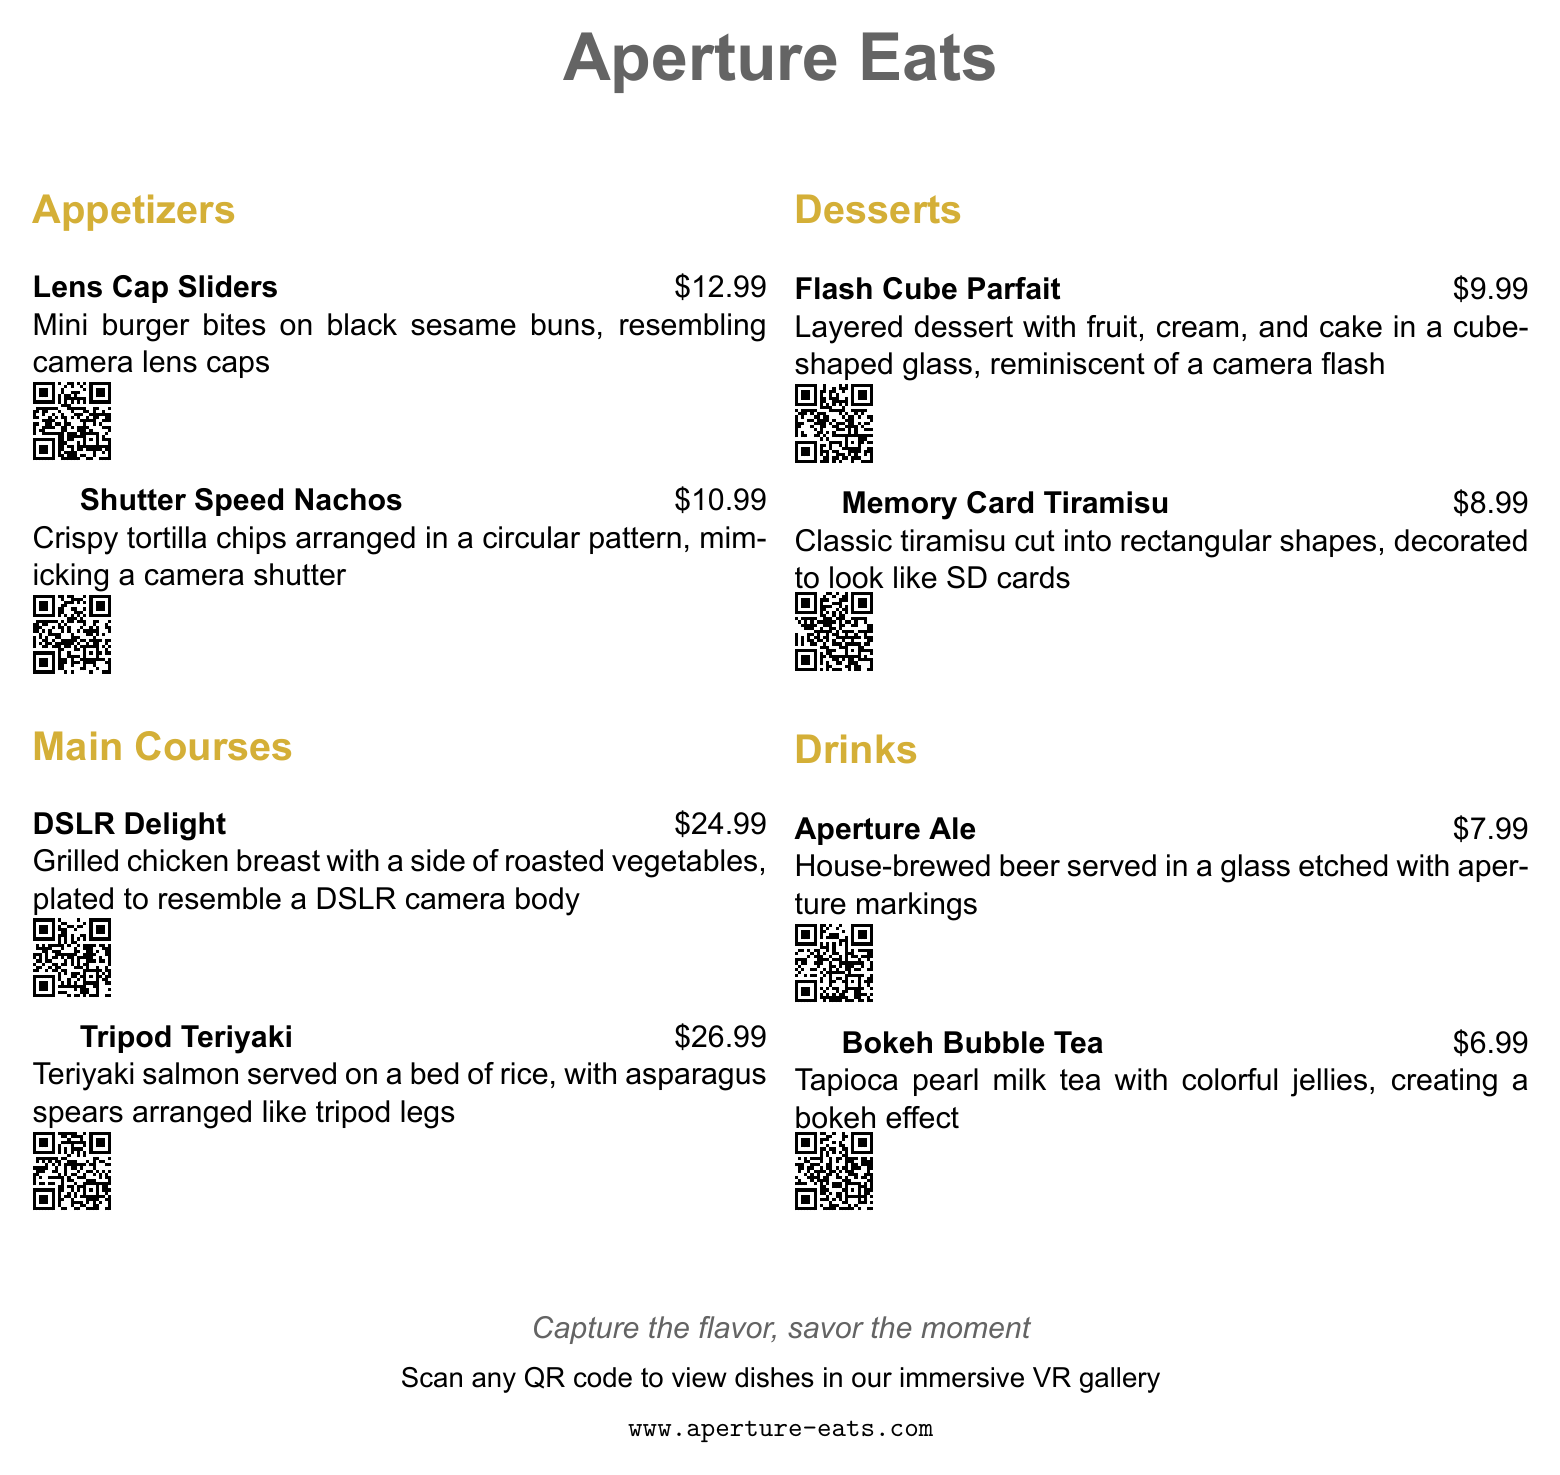What is the name of the restaurant? The name of the restaurant is prominently displayed at the top of the document as the title.
Answer: Aperture Eats How much do the Lens Cap Sliders cost? The cost of Lens Cap Sliders is mentioned next to the dish name.
Answer: $12.99 What dish resembles a DSLR camera body? The dish that is plated to resemble a DSLR camera body is specified in the main courses section.
Answer: DSLR Delight What is the price of the Bokeh Bubble Tea? The price of Bokeh Bubble Tea can be found next to the dish name in the drinks section.
Answer: $6.99 Which dessert is decorated to look like SD cards? The dessert that resembles SD cards is listed among the desserts, with a description provided.
Answer: Memory Card Tiramisu How is the Shutter Speed Nachos arranged? The arrangement of the Shutter Speed Nachos is described in the menu, detailing its visual presentation.
Answer: Circular pattern What type of beer is served in the restaurant? The type of beer mentioned in the drinks section is specific to the menu theme.
Answer: House-brewed beer How many appetizers are listed in the menu? The number of appetizers can be counted from the appetizers section provided in the document.
Answer: 2 What visual effect is created by the Bokeh Bubble Tea? The visual effect associated with the Bokeh Bubble Tea is described in the drinks section.
Answer: Bokeh effect 